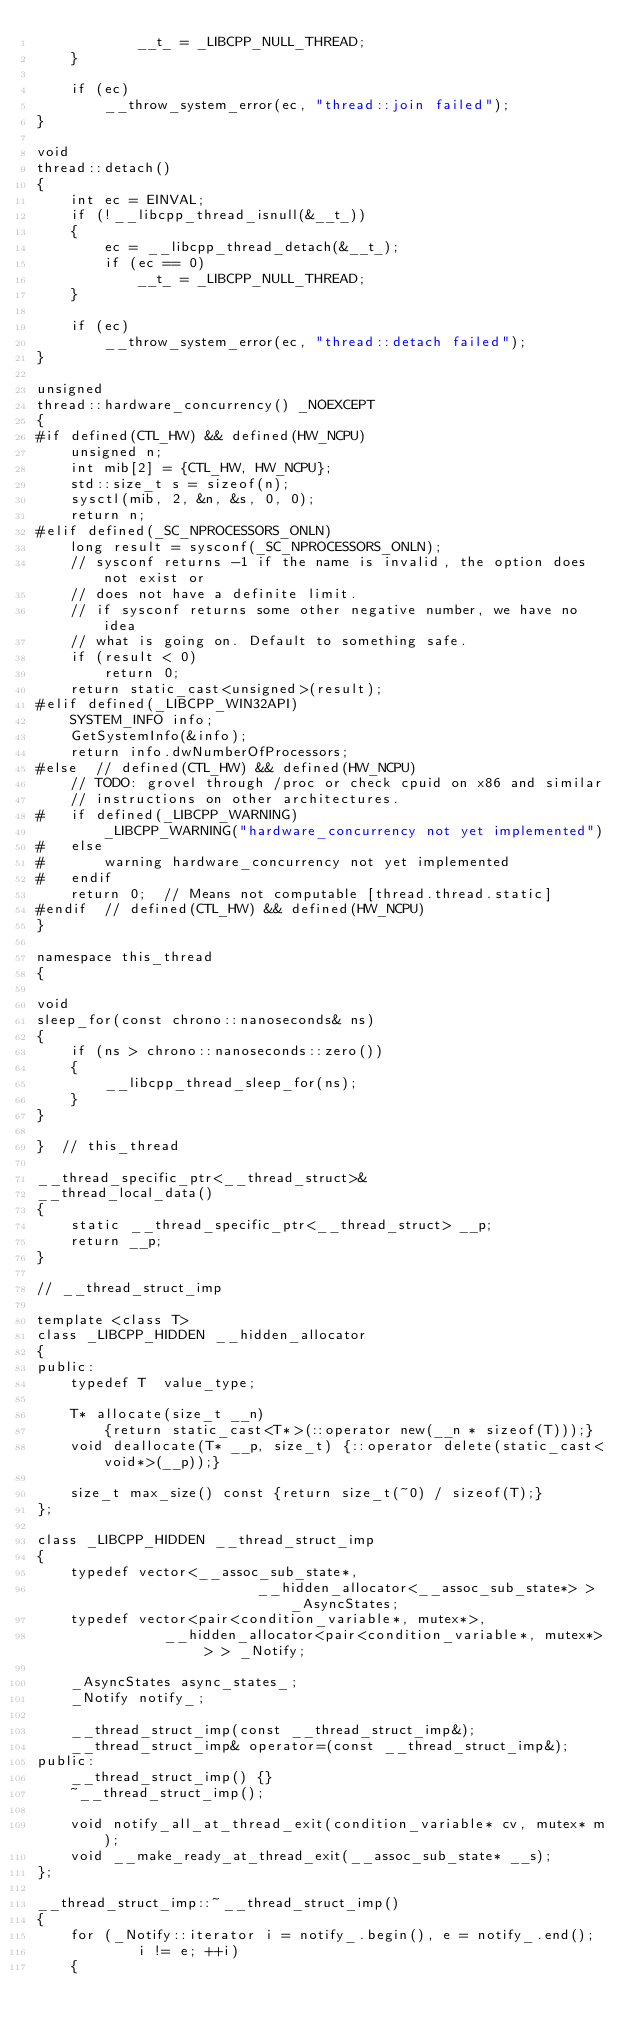Convert code to text. <code><loc_0><loc_0><loc_500><loc_500><_C++_>            __t_ = _LIBCPP_NULL_THREAD;
    }

    if (ec)
        __throw_system_error(ec, "thread::join failed");
}

void
thread::detach()
{
    int ec = EINVAL;
    if (!__libcpp_thread_isnull(&__t_))
    {
        ec = __libcpp_thread_detach(&__t_);
        if (ec == 0)
            __t_ = _LIBCPP_NULL_THREAD;
    }

    if (ec)
        __throw_system_error(ec, "thread::detach failed");
}

unsigned
thread::hardware_concurrency() _NOEXCEPT
{
#if defined(CTL_HW) && defined(HW_NCPU)
    unsigned n;
    int mib[2] = {CTL_HW, HW_NCPU};
    std::size_t s = sizeof(n);
    sysctl(mib, 2, &n, &s, 0, 0);
    return n;
#elif defined(_SC_NPROCESSORS_ONLN)
    long result = sysconf(_SC_NPROCESSORS_ONLN);
    // sysconf returns -1 if the name is invalid, the option does not exist or
    // does not have a definite limit.
    // if sysconf returns some other negative number, we have no idea
    // what is going on. Default to something safe.
    if (result < 0)
        return 0;
    return static_cast<unsigned>(result);
#elif defined(_LIBCPP_WIN32API)
    SYSTEM_INFO info;
    GetSystemInfo(&info);
    return info.dwNumberOfProcessors;
#else  // defined(CTL_HW) && defined(HW_NCPU)
    // TODO: grovel through /proc or check cpuid on x86 and similar
    // instructions on other architectures.
#   if defined(_LIBCPP_WARNING)
        _LIBCPP_WARNING("hardware_concurrency not yet implemented")
#   else
#       warning hardware_concurrency not yet implemented
#   endif
    return 0;  // Means not computable [thread.thread.static]
#endif  // defined(CTL_HW) && defined(HW_NCPU)
}

namespace this_thread
{

void
sleep_for(const chrono::nanoseconds& ns)
{
    if (ns > chrono::nanoseconds::zero())
    {
        __libcpp_thread_sleep_for(ns);
    }
}

}  // this_thread

__thread_specific_ptr<__thread_struct>&
__thread_local_data()
{
    static __thread_specific_ptr<__thread_struct> __p;
    return __p;
}

// __thread_struct_imp

template <class T>
class _LIBCPP_HIDDEN __hidden_allocator
{
public:
    typedef T  value_type;
    
    T* allocate(size_t __n)
        {return static_cast<T*>(::operator new(__n * sizeof(T)));}
    void deallocate(T* __p, size_t) {::operator delete(static_cast<void*>(__p));}

    size_t max_size() const {return size_t(~0) / sizeof(T);}
};

class _LIBCPP_HIDDEN __thread_struct_imp
{
    typedef vector<__assoc_sub_state*,
                          __hidden_allocator<__assoc_sub_state*> > _AsyncStates;
    typedef vector<pair<condition_variable*, mutex*>,
               __hidden_allocator<pair<condition_variable*, mutex*> > > _Notify;

    _AsyncStates async_states_;
    _Notify notify_;

    __thread_struct_imp(const __thread_struct_imp&);
    __thread_struct_imp& operator=(const __thread_struct_imp&);
public:
    __thread_struct_imp() {}
    ~__thread_struct_imp();

    void notify_all_at_thread_exit(condition_variable* cv, mutex* m);
    void __make_ready_at_thread_exit(__assoc_sub_state* __s);
};

__thread_struct_imp::~__thread_struct_imp()
{
    for (_Notify::iterator i = notify_.begin(), e = notify_.end();
            i != e; ++i)
    {</code> 